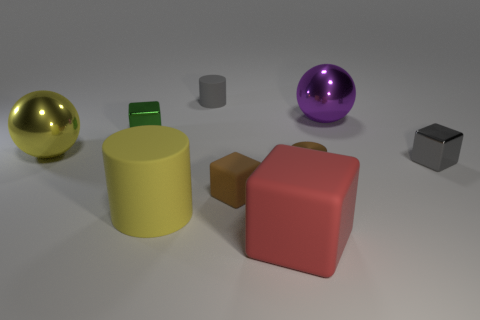There is a small object that is the same color as the small rubber cylinder; what material is it?
Your answer should be very brief. Metal. What is the material of the purple thing?
Your response must be concise. Metal. There is a ball that is right of the green metallic cube; what color is it?
Give a very brief answer. Purple. Are there more cubes that are to the left of the big purple ball than tiny gray blocks that are behind the green metallic cube?
Provide a succinct answer. Yes. What size is the rubber object in front of the large yellow matte object that is in front of the large object to the left of the tiny green shiny block?
Make the answer very short. Large. Are there any tiny metal cubes of the same color as the tiny rubber cylinder?
Your answer should be compact. Yes. What number of large cylinders are there?
Offer a very short reply. 1. There is a big yellow object on the left side of the tiny block behind the large sphere on the left side of the large yellow cylinder; what is its material?
Your response must be concise. Metal. Are there any big yellow things that have the same material as the tiny green thing?
Your answer should be very brief. Yes. Are the red object and the brown block made of the same material?
Offer a terse response. Yes. 